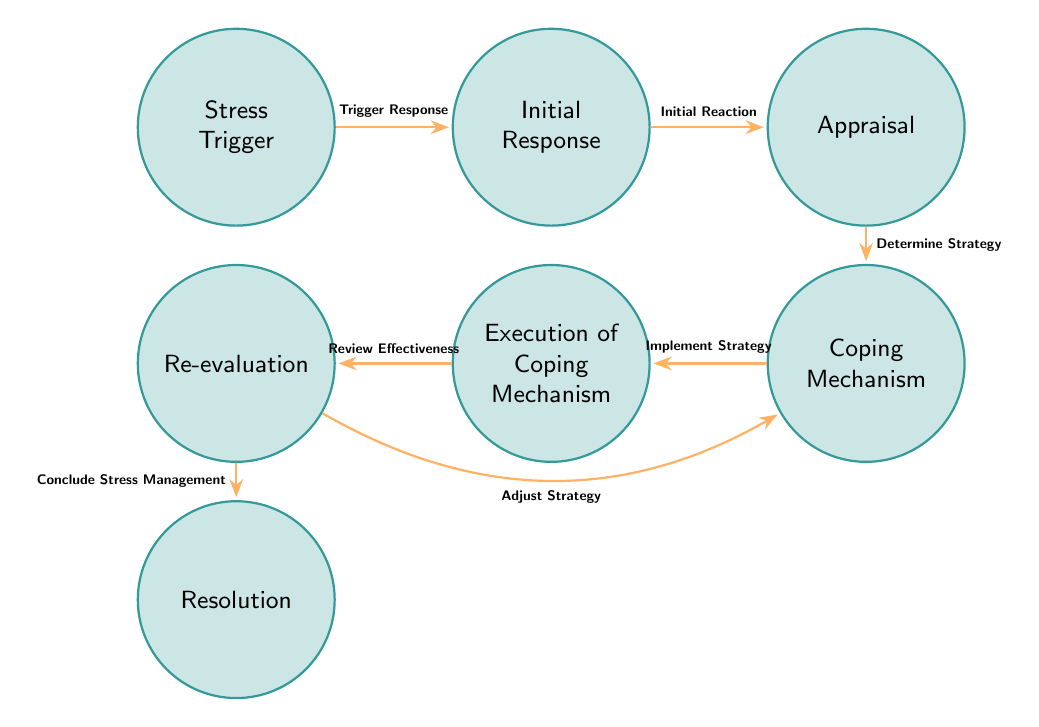What is the first node in the sequence? The first node in the sequence is identified as "Stress Trigger," which signifies the starting point of the diagram.
Answer: Stress Trigger How many nodes are present in the diagram? By counting the nodes listed in the provided data, there are a total of 7 nodes in the diagram.
Answer: 7 Which node follows "Initial Response"? The node that follows "Initial Response" in the sequence is "Appraisal," as indicated by the directional transition from node 2 to node 3.
Answer: Appraisal What is the name of the transition from "Appraisal" to "Coping Mechanism"? The transition between these two nodes is named "Determine Strategy," indicating the process of choosing a coping mechanism.
Answer: Determine Strategy In which direction does the "Review Effectiveness" transition lead? The "Review Effectiveness" transition leads to two possible nodes: "Resolution" and "Coping Mechanism." This indicates that after evaluating the coping strategy, the student can either reach a resolution or adjust their coping mechanism if necessary.
Answer: Resolution, Coping Mechanism What is the purpose of the node "Re-evaluation"? The purpose of the "Re-evaluation" node is to assess the effectiveness of the coping mechanisms that were executed, which is essential for determining whether to conclude stress management or adjust strategies.
Answer: Assess effectiveness What happens if the coping mechanism is not effective, as indicated in the diagram? If the coping mechanism is deemed ineffective during "Re-evaluation," the diagram indicates that there is a transition back to the "Coping Mechanism" node, where new strategies can be formulated.
Answer: Adjust Strategy Which node signifies the successful management of stress? The node that signifies the successful management of stress is the "Resolution" node, indicating that the stress has been managed effectively.
Answer: Resolution 